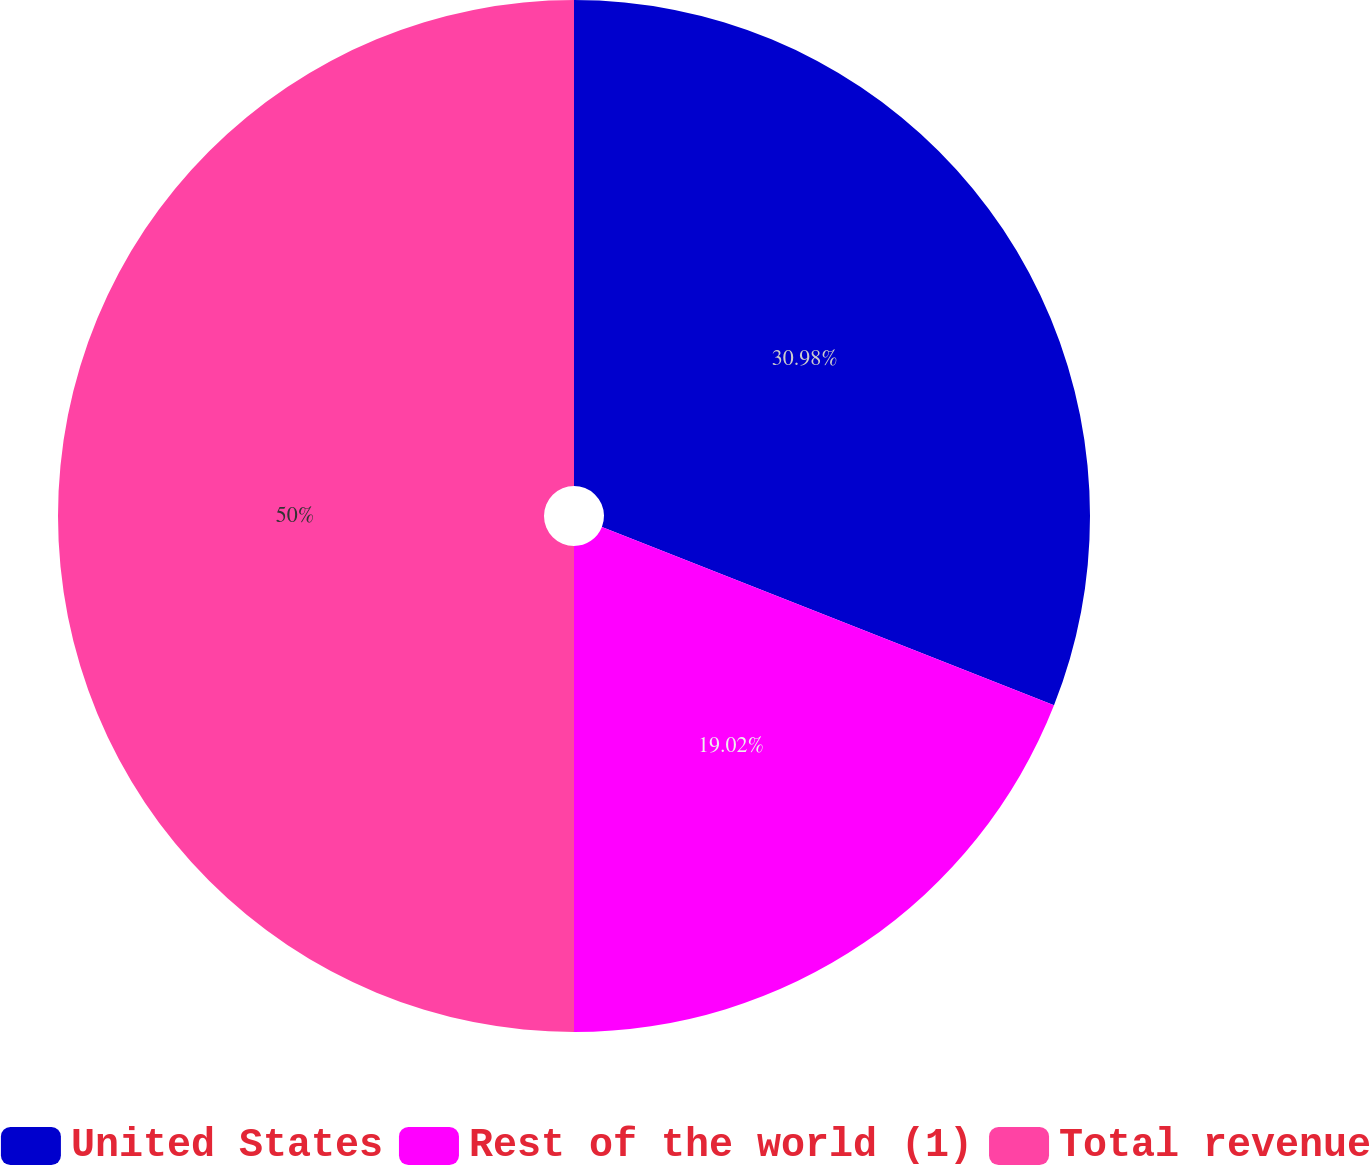Convert chart. <chart><loc_0><loc_0><loc_500><loc_500><pie_chart><fcel>United States<fcel>Rest of the world (1)<fcel>Total revenue<nl><fcel>30.98%<fcel>19.02%<fcel>50.0%<nl></chart> 